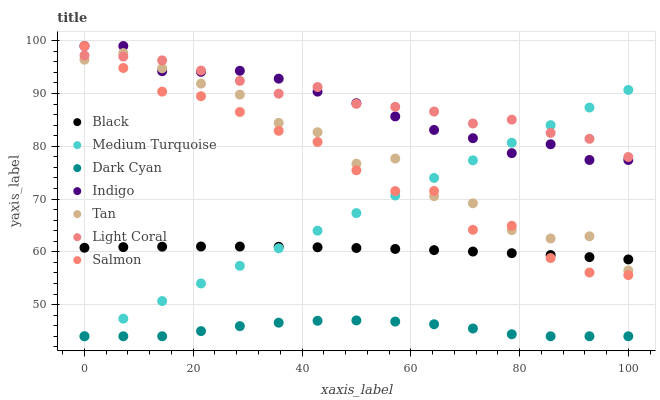Does Dark Cyan have the minimum area under the curve?
Answer yes or no. Yes. Does Light Coral have the maximum area under the curve?
Answer yes or no. Yes. Does Salmon have the minimum area under the curve?
Answer yes or no. No. Does Salmon have the maximum area under the curve?
Answer yes or no. No. Is Medium Turquoise the smoothest?
Answer yes or no. Yes. Is Tan the roughest?
Answer yes or no. Yes. Is Salmon the smoothest?
Answer yes or no. No. Is Salmon the roughest?
Answer yes or no. No. Does Medium Turquoise have the lowest value?
Answer yes or no. Yes. Does Salmon have the lowest value?
Answer yes or no. No. Does Salmon have the highest value?
Answer yes or no. Yes. Does Light Coral have the highest value?
Answer yes or no. No. Is Black less than Indigo?
Answer yes or no. Yes. Is Indigo greater than Black?
Answer yes or no. Yes. Does Medium Turquoise intersect Indigo?
Answer yes or no. Yes. Is Medium Turquoise less than Indigo?
Answer yes or no. No. Is Medium Turquoise greater than Indigo?
Answer yes or no. No. Does Black intersect Indigo?
Answer yes or no. No. 